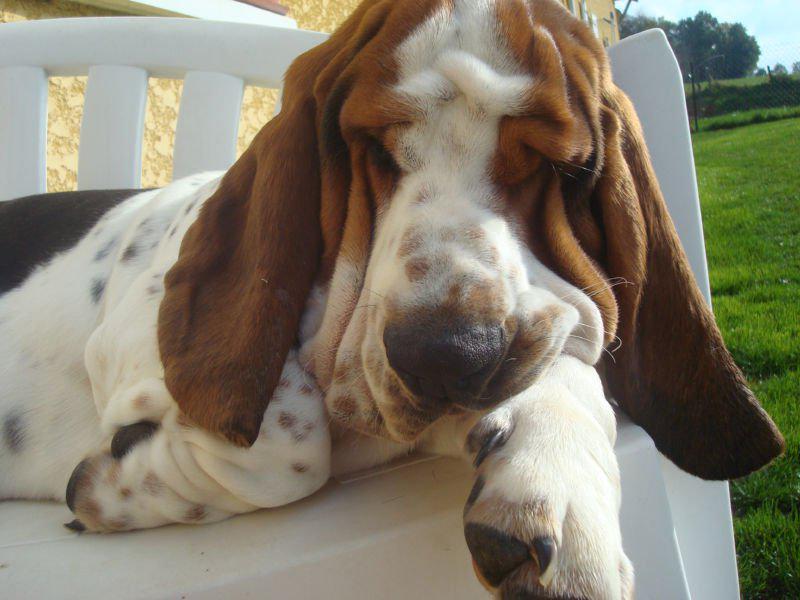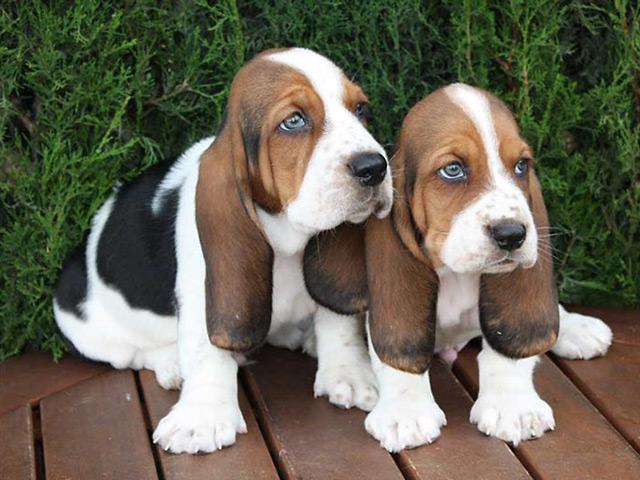The first image is the image on the left, the second image is the image on the right. Assess this claim about the two images: "There is exactly two dogs in the left image.". Correct or not? Answer yes or no. No. The first image is the image on the left, the second image is the image on the right. Given the left and right images, does the statement "The right image shows one basset hound reclining on the ground, and the left image shows two hounds interacting." hold true? Answer yes or no. No. 